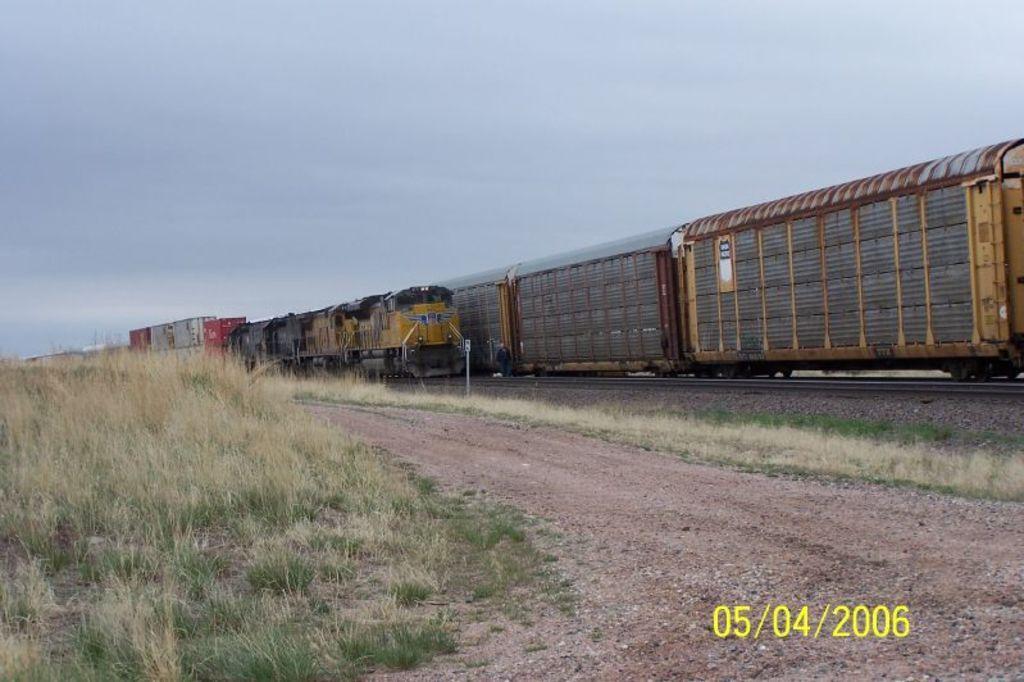Can you describe this image briefly? In this image we can see the trains on the railway tracks. We can also see the grass, stones and also the land. In the background, we can see the sky and we can also see the date on the right. 